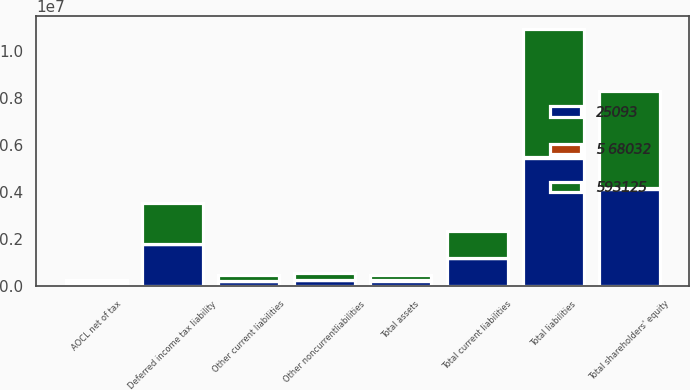Convert chart. <chart><loc_0><loc_0><loc_500><loc_500><stacked_bar_chart><ecel><fcel>Total assets<fcel>Other current liabilities<fcel>Total current liabilities<fcel>Deferred income tax liability<fcel>Other noncurrentliabilities<fcel>Total liabilities<fcel>AOCL net of tax<fcel>Total shareholders' equity<nl><fcel>25093<fcel>234319<fcel>233246<fcel>1.18212e+06<fcel>1.77858e+06<fcel>248431<fcel>5.4665e+06<fcel>107108<fcel>4.14722e+06<nl><fcel>5 68032<fcel>25093<fcel>2146<fcel>2146<fcel>20127<fcel>26289<fcel>8308<fcel>33401<fcel>33401<nl><fcel>593125<fcel>234319<fcel>235392<fcel>1.18426e+06<fcel>1.75845e+06<fcel>274720<fcel>5.47481e+06<fcel>140509<fcel>4.11382e+06<nl></chart> 